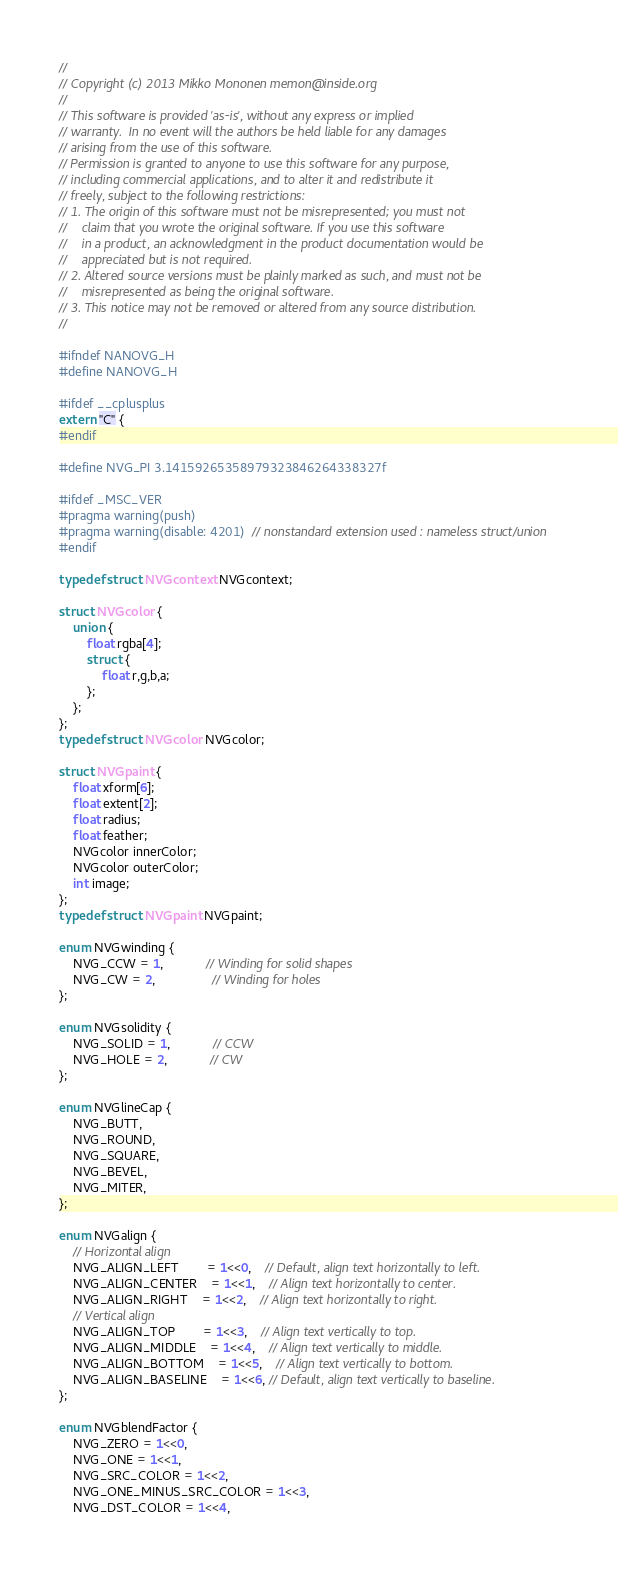<code> <loc_0><loc_0><loc_500><loc_500><_C_>//
// Copyright (c) 2013 Mikko Mononen memon@inside.org
//
// This software is provided 'as-is', without any express or implied
// warranty.  In no event will the authors be held liable for any damages
// arising from the use of this software.
// Permission is granted to anyone to use this software for any purpose,
// including commercial applications, and to alter it and redistribute it
// freely, subject to the following restrictions:
// 1. The origin of this software must not be misrepresented; you must not
//    claim that you wrote the original software. If you use this software
//    in a product, an acknowledgment in the product documentation would be
//    appreciated but is not required.
// 2. Altered source versions must be plainly marked as such, and must not be
//    misrepresented as being the original software.
// 3. This notice may not be removed or altered from any source distribution.
//

#ifndef NANOVG_H
#define NANOVG_H

#ifdef __cplusplus
extern "C" {
#endif

#define NVG_PI 3.14159265358979323846264338327f

#ifdef _MSC_VER
#pragma warning(push)
#pragma warning(disable: 4201)  // nonstandard extension used : nameless struct/union
#endif

typedef struct NVGcontext NVGcontext;

struct NVGcolor {
	union {
		float rgba[4];
		struct {
			float r,g,b,a;
		};
	};
};
typedef struct NVGcolor NVGcolor;

struct NVGpaint {
	float xform[6];
	float extent[2];
	float radius;
	float feather;
	NVGcolor innerColor;
	NVGcolor outerColor;
	int image;
};
typedef struct NVGpaint NVGpaint;

enum NVGwinding {
	NVG_CCW = 1,			// Winding for solid shapes
	NVG_CW = 2,				// Winding for holes
};

enum NVGsolidity {
	NVG_SOLID = 1,			// CCW
	NVG_HOLE = 2,			// CW
};

enum NVGlineCap {
	NVG_BUTT,
	NVG_ROUND,
	NVG_SQUARE,
	NVG_BEVEL,
	NVG_MITER,
};

enum NVGalign {
	// Horizontal align
	NVG_ALIGN_LEFT 		= 1<<0,	// Default, align text horizontally to left.
	NVG_ALIGN_CENTER 	= 1<<1,	// Align text horizontally to center.
	NVG_ALIGN_RIGHT 	= 1<<2,	// Align text horizontally to right.
	// Vertical align
	NVG_ALIGN_TOP 		= 1<<3,	// Align text vertically to top.
	NVG_ALIGN_MIDDLE	= 1<<4,	// Align text vertically to middle.
	NVG_ALIGN_BOTTOM	= 1<<5,	// Align text vertically to bottom.
	NVG_ALIGN_BASELINE	= 1<<6, // Default, align text vertically to baseline.
};

enum NVGblendFactor {
	NVG_ZERO = 1<<0,
	NVG_ONE = 1<<1,
	NVG_SRC_COLOR = 1<<2,
	NVG_ONE_MINUS_SRC_COLOR = 1<<3,
	NVG_DST_COLOR = 1<<4,</code> 